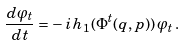Convert formula to latex. <formula><loc_0><loc_0><loc_500><loc_500>\frac { d \varphi _ { t } } { d t } = - \, i \, h _ { 1 } ( \Phi ^ { t } ( q , p ) ) \, \varphi _ { t } \, .</formula> 